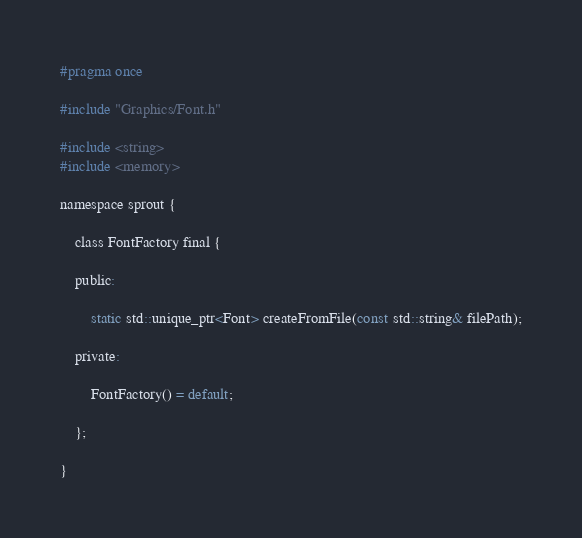Convert code to text. <code><loc_0><loc_0><loc_500><loc_500><_C_>#pragma once

#include "Graphics/Font.h"

#include <string>
#include <memory>

namespace sprout {

    class FontFactory final {

    public:

        static std::unique_ptr<Font> createFromFile(const std::string& filePath);

    private:

        FontFactory() = default;

    };

}</code> 